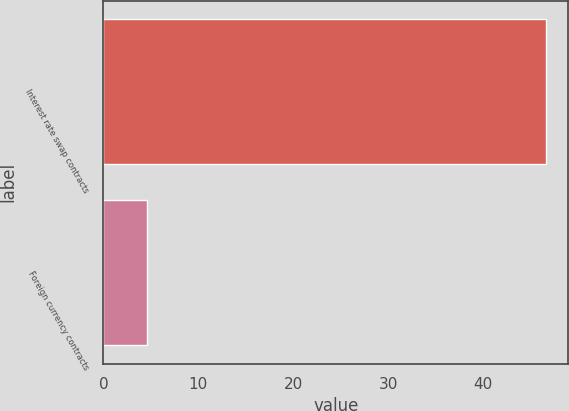<chart> <loc_0><loc_0><loc_500><loc_500><bar_chart><fcel>Interest rate swap contracts<fcel>Foreign currency contracts<nl><fcel>46.6<fcel>4.6<nl></chart> 